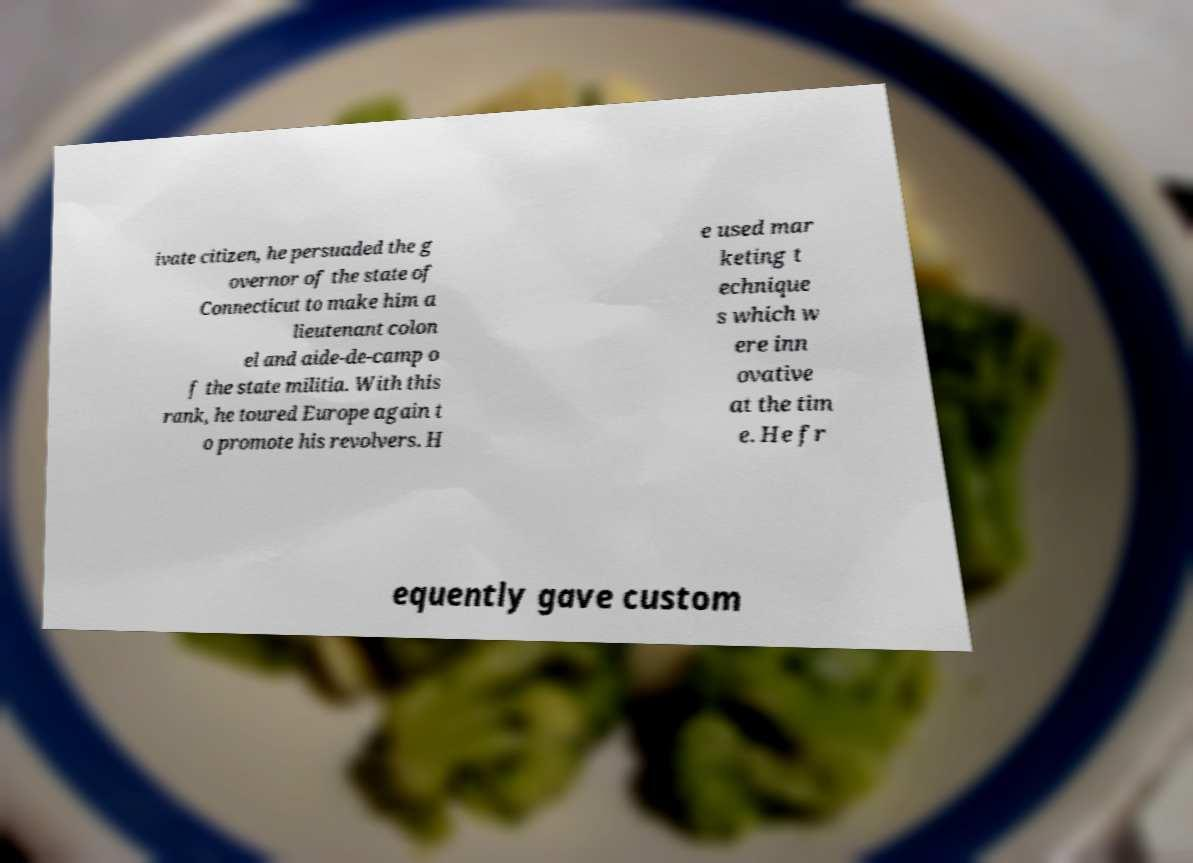Can you accurately transcribe the text from the provided image for me? ivate citizen, he persuaded the g overnor of the state of Connecticut to make him a lieutenant colon el and aide-de-camp o f the state militia. With this rank, he toured Europe again t o promote his revolvers. H e used mar keting t echnique s which w ere inn ovative at the tim e. He fr equently gave custom 